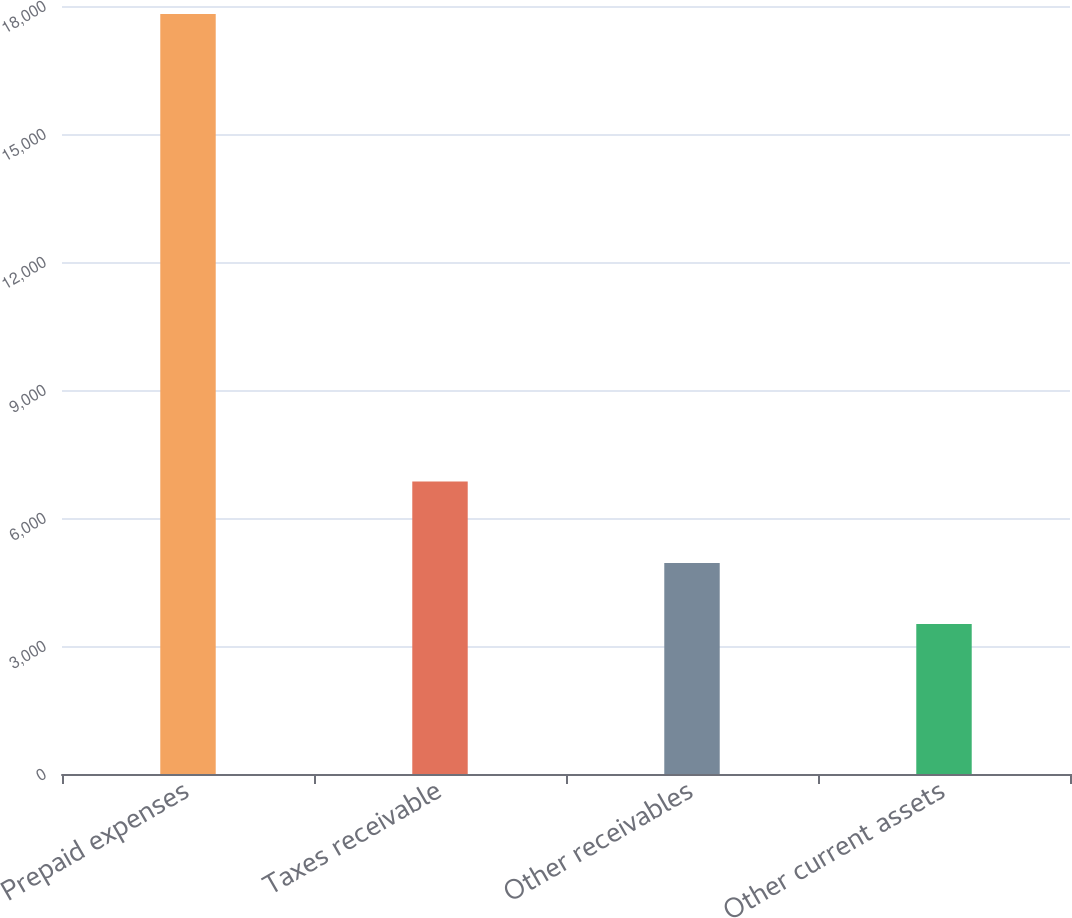Convert chart to OTSL. <chart><loc_0><loc_0><loc_500><loc_500><bar_chart><fcel>Prepaid expenses<fcel>Taxes receivable<fcel>Other receivables<fcel>Other current assets<nl><fcel>17810<fcel>6857<fcel>4944.5<fcel>3515<nl></chart> 